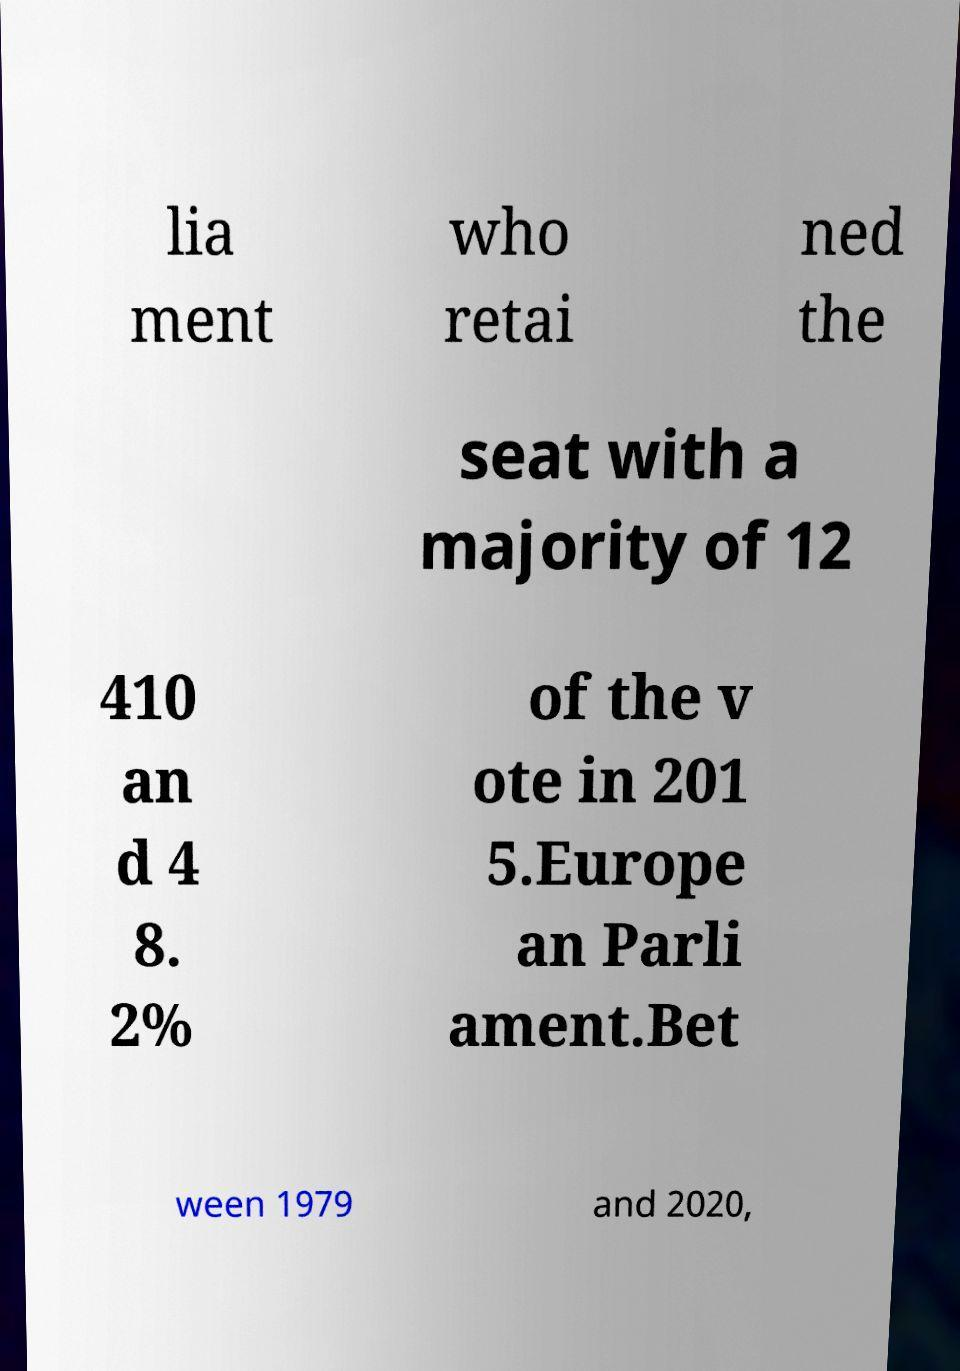Can you read and provide the text displayed in the image?This photo seems to have some interesting text. Can you extract and type it out for me? lia ment who retai ned the seat with a majority of 12 410 an d 4 8. 2% of the v ote in 201 5.Europe an Parli ament.Bet ween 1979 and 2020, 